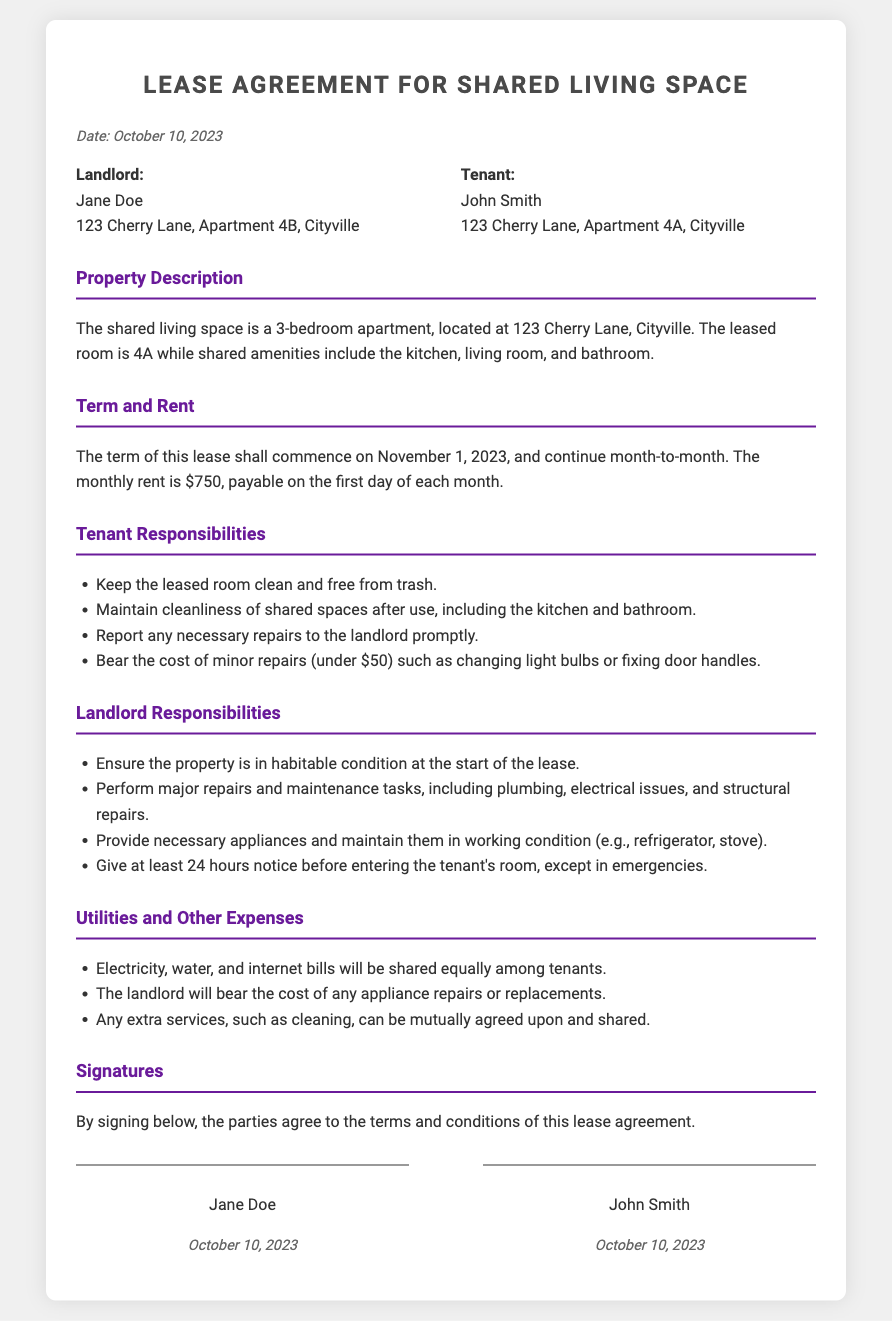What is the name of the landlord? The landlord's name is explicitly mentioned in the document under the landlord section.
Answer: Jane Doe What is the monthly rent amount? The amount of rent is specified in the term and rent section of the document.
Answer: $750 What is the starting date of the lease? The commencement date of the lease is clearly stated in the term and rent section.
Answer: November 1, 2023 What responsibilities does the tenant have regarding shared spaces? The document lists specific tenant responsibilities in a dedicated section.
Answer: Maintain cleanliness of shared spaces after use Who is responsible for major repairs? The landlord's responsibilities section clearly states who handles major repairs.
Answer: Landlord What will be shared equally among tenants? There is a section in the document that specifies shared expenses.
Answer: Electricity, water, and internet bills How much does the tenant have to bear for minor repairs? The specific cost limit for tenant responsibilities regarding minor repairs is detailed in the tenant responsibilities section.
Answer: Under $50 What is required from the landlord before entering the tenant's room? The landlord's responsibilities state the condition for entering the tenant's room.
Answer: At least 24 hours notice What type of lease is described in the document? The type of lease can be inferred from the term and rent section.
Answer: Month-to-month 